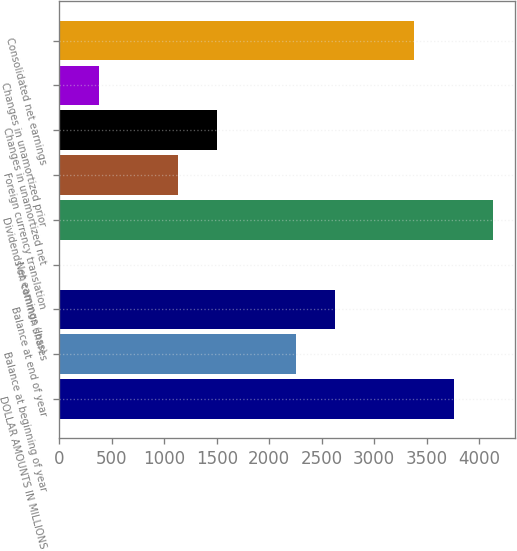Convert chart to OTSL. <chart><loc_0><loc_0><loc_500><loc_500><bar_chart><fcel>DOLLAR AMOUNTS IN MILLIONS<fcel>Balance at beginning of year<fcel>Balance at end of year<fcel>Net earnings (loss)<fcel>Dividends on common shares<fcel>Foreign currency translation<fcel>Changes in unamortized net<fcel>Changes in unamortized prior<fcel>Consolidated net earnings<nl><fcel>3758<fcel>2255.6<fcel>2631.2<fcel>2<fcel>4133.6<fcel>1128.8<fcel>1504.4<fcel>377.6<fcel>3382.4<nl></chart> 